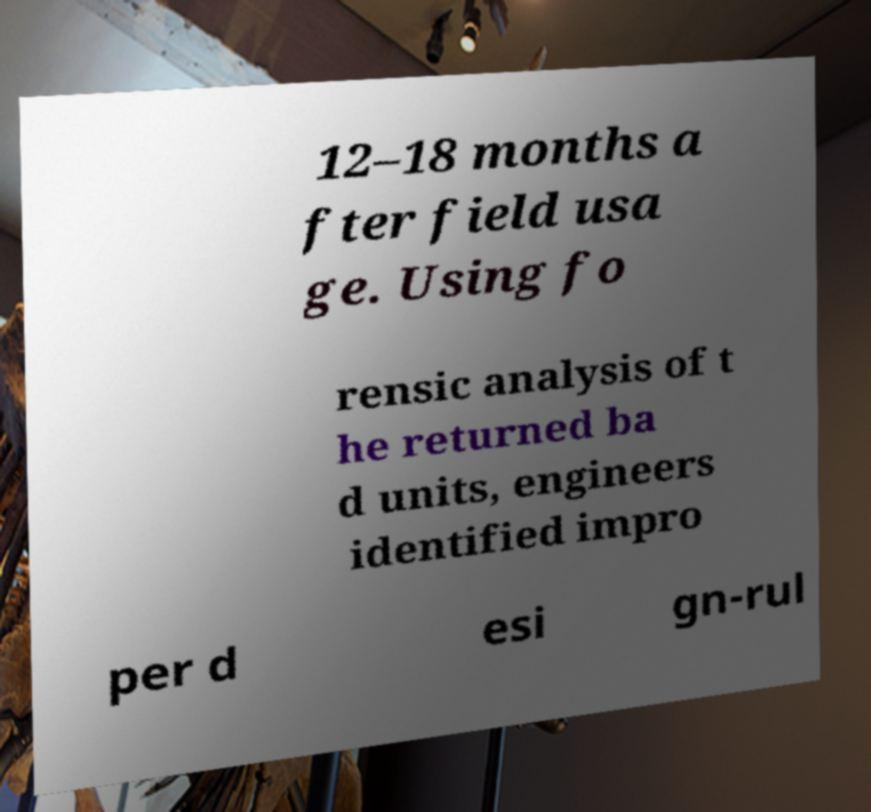Could you assist in decoding the text presented in this image and type it out clearly? 12–18 months a fter field usa ge. Using fo rensic analysis of t he returned ba d units, engineers identified impro per d esi gn-rul 